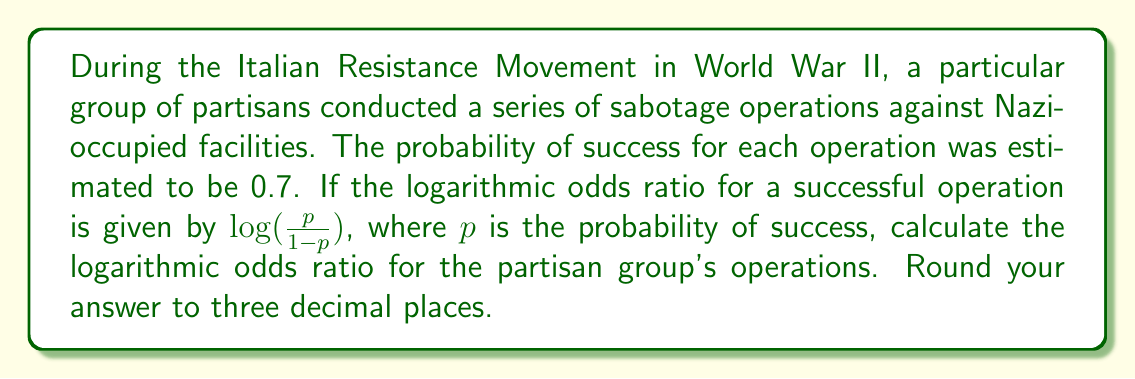Help me with this question. To solve this problem, we'll follow these steps:

1) First, let's recall the formula for the logarithmic odds ratio:

   $\text{Logarithmic odds ratio} = \log(\frac{p}{1-p})$

   Where $p$ is the probability of success.

2) We're given that the probability of success ($p$) for each operation is 0.7.

3) Let's substitute this into our formula:

   $\text{Logarithmic odds ratio} = \log(\frac{0.7}{1-0.7})$

4) Simplify the fraction inside the logarithm:

   $\text{Logarithmic odds ratio} = \log(\frac{0.7}{0.3})$

5) Divide 0.7 by 0.3:

   $\text{Logarithmic odds ratio} = \log(2.3333...)$

6) Now we need to calculate the natural logarithm of this value. Using a calculator:

   $\text{Logarithmic odds ratio} \approx 0.847$

7) Rounding to three decimal places:

   $\text{Logarithmic odds ratio} \approx 0.847$

This value indicates that the odds of success are higher than the odds of failure, which aligns with the original probability of 0.7 (greater than 0.5).
Answer: $0.847$ 